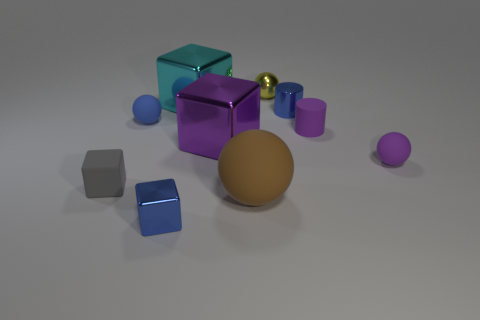Subtract all cubes. How many objects are left? 6 Add 4 tiny purple cylinders. How many tiny purple cylinders exist? 5 Subtract 1 cyan cubes. How many objects are left? 9 Subtract all matte blocks. Subtract all purple matte cylinders. How many objects are left? 8 Add 8 blue matte spheres. How many blue matte spheres are left? 9 